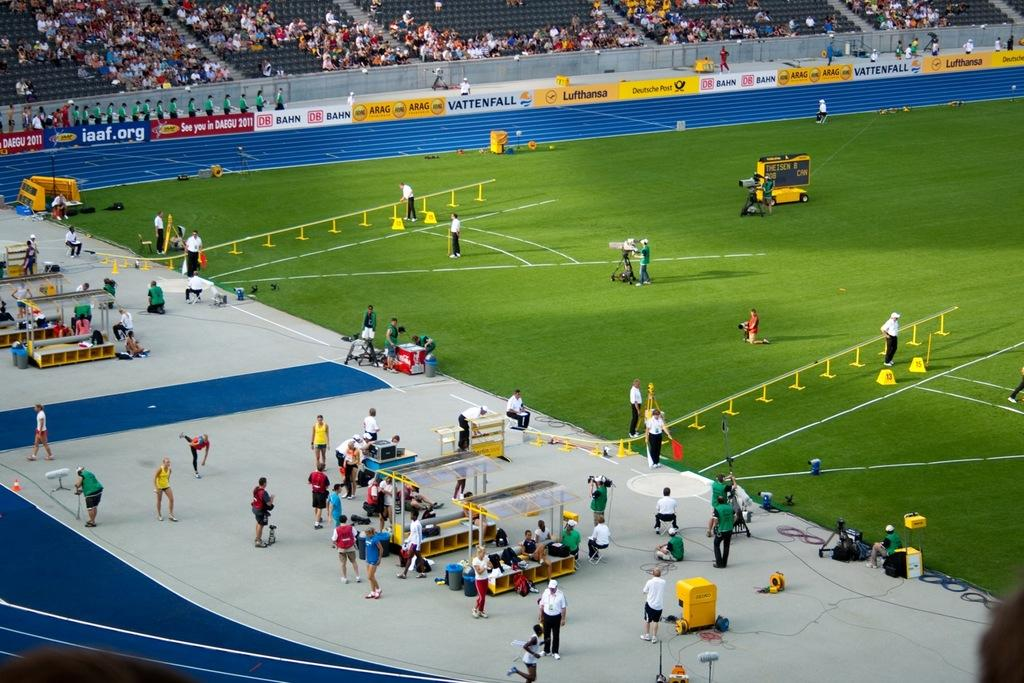What are the people in the image doing? There are persons standing on the ground and little people sitting in the image. What can be seen in the image that might be used to control the movement of people? There are barriers in the image. Who might be watching the people in the image? There are spectators in the image. What is the color of the grass in the image? There is green grass in the image. What type of signage is present in the image? There are hoardings in the image. What type of crate is being used by the organization in the image? There is no crate or organization present in the image. What type of church can be seen in the background of the image? There is no church visible in the image. 